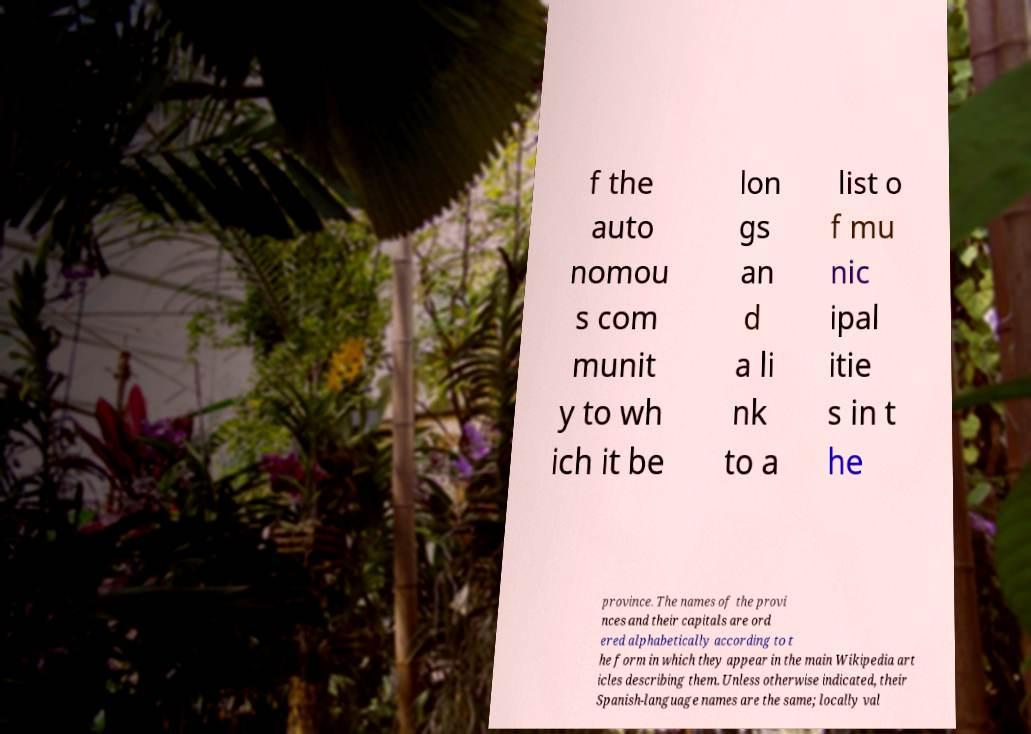I need the written content from this picture converted into text. Can you do that? f the auto nomou s com munit y to wh ich it be lon gs an d a li nk to a list o f mu nic ipal itie s in t he province. The names of the provi nces and their capitals are ord ered alphabetically according to t he form in which they appear in the main Wikipedia art icles describing them. Unless otherwise indicated, their Spanish-language names are the same; locally val 